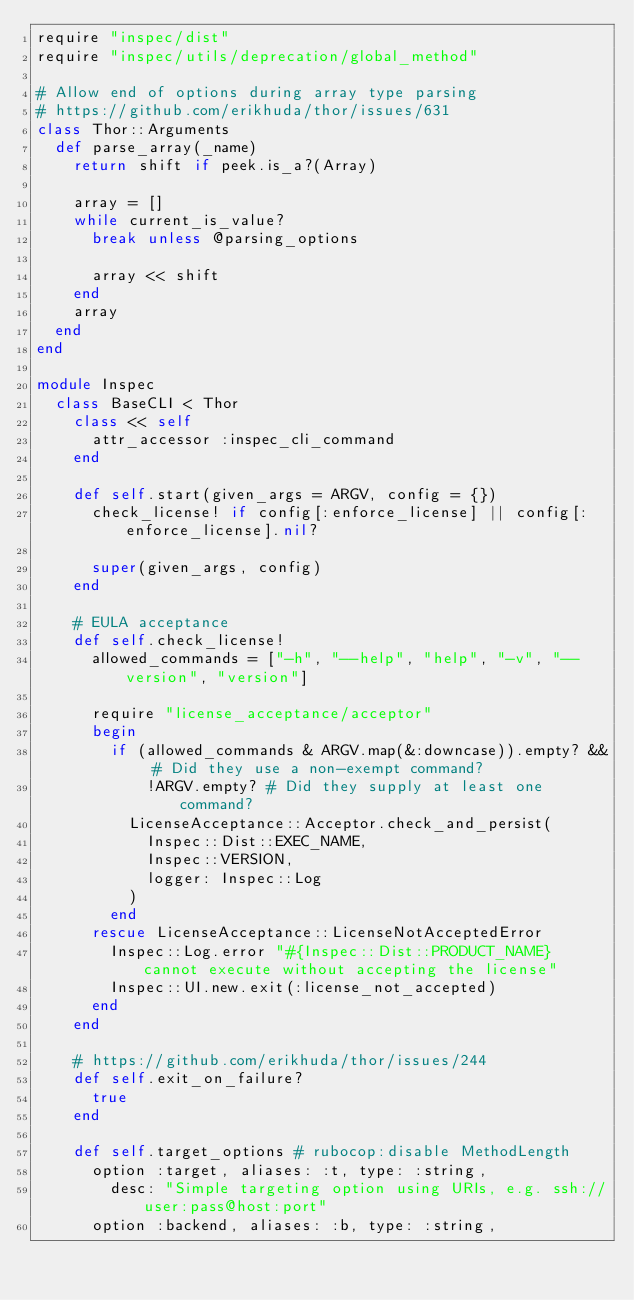Convert code to text. <code><loc_0><loc_0><loc_500><loc_500><_Ruby_>require "inspec/dist"
require "inspec/utils/deprecation/global_method"

# Allow end of options during array type parsing
# https://github.com/erikhuda/thor/issues/631
class Thor::Arguments
  def parse_array(_name)
    return shift if peek.is_a?(Array)

    array = []
    while current_is_value?
      break unless @parsing_options

      array << shift
    end
    array
  end
end

module Inspec
  class BaseCLI < Thor
    class << self
      attr_accessor :inspec_cli_command
    end

    def self.start(given_args = ARGV, config = {})
      check_license! if config[:enforce_license] || config[:enforce_license].nil?

      super(given_args, config)
    end

    # EULA acceptance
    def self.check_license!
      allowed_commands = ["-h", "--help", "help", "-v", "--version", "version"]

      require "license_acceptance/acceptor"
      begin
        if (allowed_commands & ARGV.map(&:downcase)).empty? && # Did they use a non-exempt command?
            !ARGV.empty? # Did they supply at least one command?
          LicenseAcceptance::Acceptor.check_and_persist(
            Inspec::Dist::EXEC_NAME,
            Inspec::VERSION,
            logger: Inspec::Log
          )
        end
      rescue LicenseAcceptance::LicenseNotAcceptedError
        Inspec::Log.error "#{Inspec::Dist::PRODUCT_NAME} cannot execute without accepting the license"
        Inspec::UI.new.exit(:license_not_accepted)
      end
    end

    # https://github.com/erikhuda/thor/issues/244
    def self.exit_on_failure?
      true
    end

    def self.target_options # rubocop:disable MethodLength
      option :target, aliases: :t, type: :string,
        desc: "Simple targeting option using URIs, e.g. ssh://user:pass@host:port"
      option :backend, aliases: :b, type: :string,</code> 